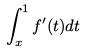<formula> <loc_0><loc_0><loc_500><loc_500>\int _ { x } ^ { 1 } f ^ { \prime } ( t ) d t</formula> 